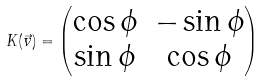<formula> <loc_0><loc_0><loc_500><loc_500>K ( \vec { v } ) = \begin{pmatrix} \cos \phi & - \sin \phi \\ \sin \phi & \cos \phi \end{pmatrix}</formula> 